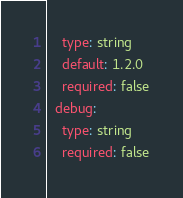<code> <loc_0><loc_0><loc_500><loc_500><_YAML_>    type: string
    default: 1.2.0
    required: false
  debug:
    type: string
    required: false
</code> 